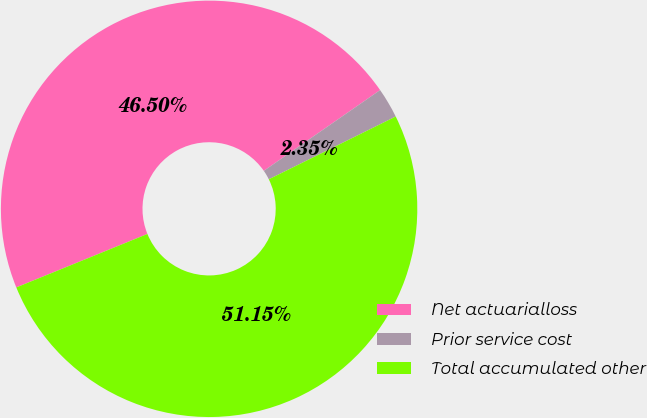Convert chart to OTSL. <chart><loc_0><loc_0><loc_500><loc_500><pie_chart><fcel>Net actuarialloss<fcel>Prior service cost<fcel>Total accumulated other<nl><fcel>46.5%<fcel>2.35%<fcel>51.15%<nl></chart> 